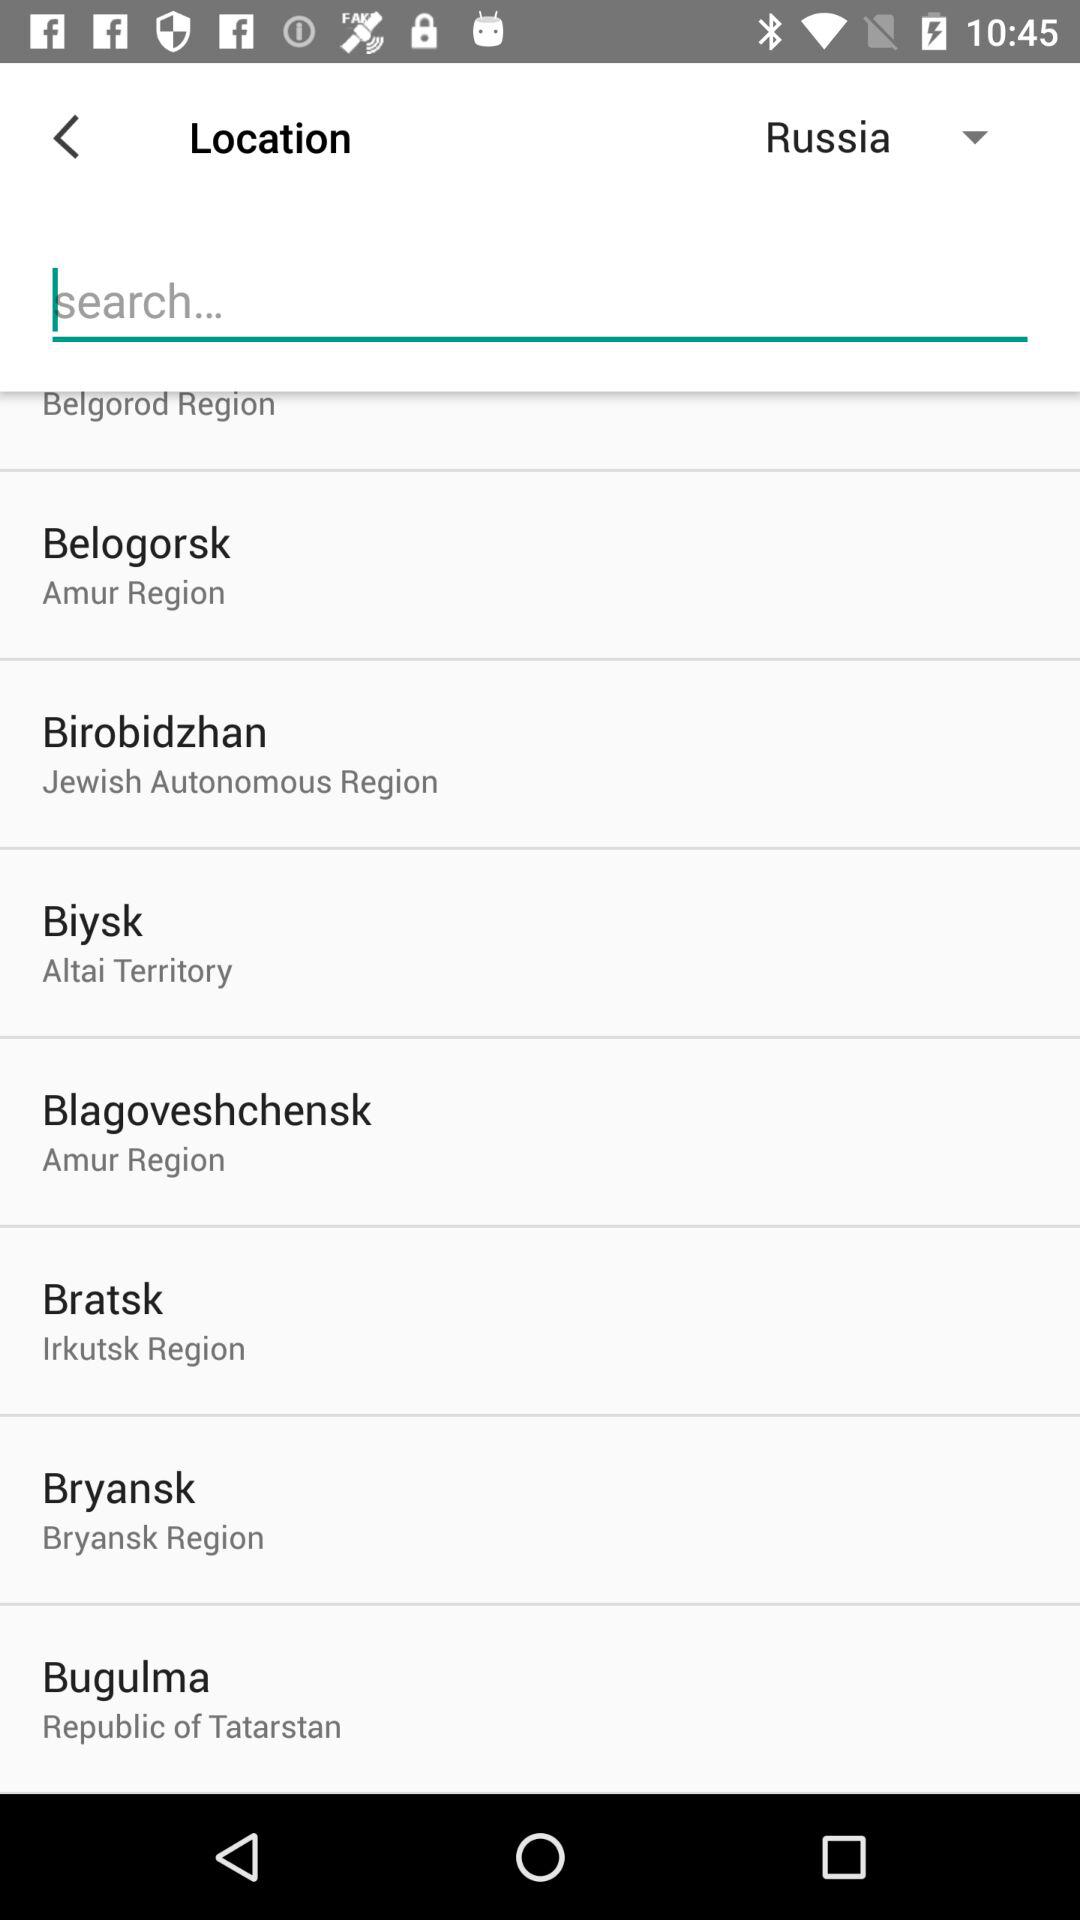What is the selected country? The selected country is Russia. 